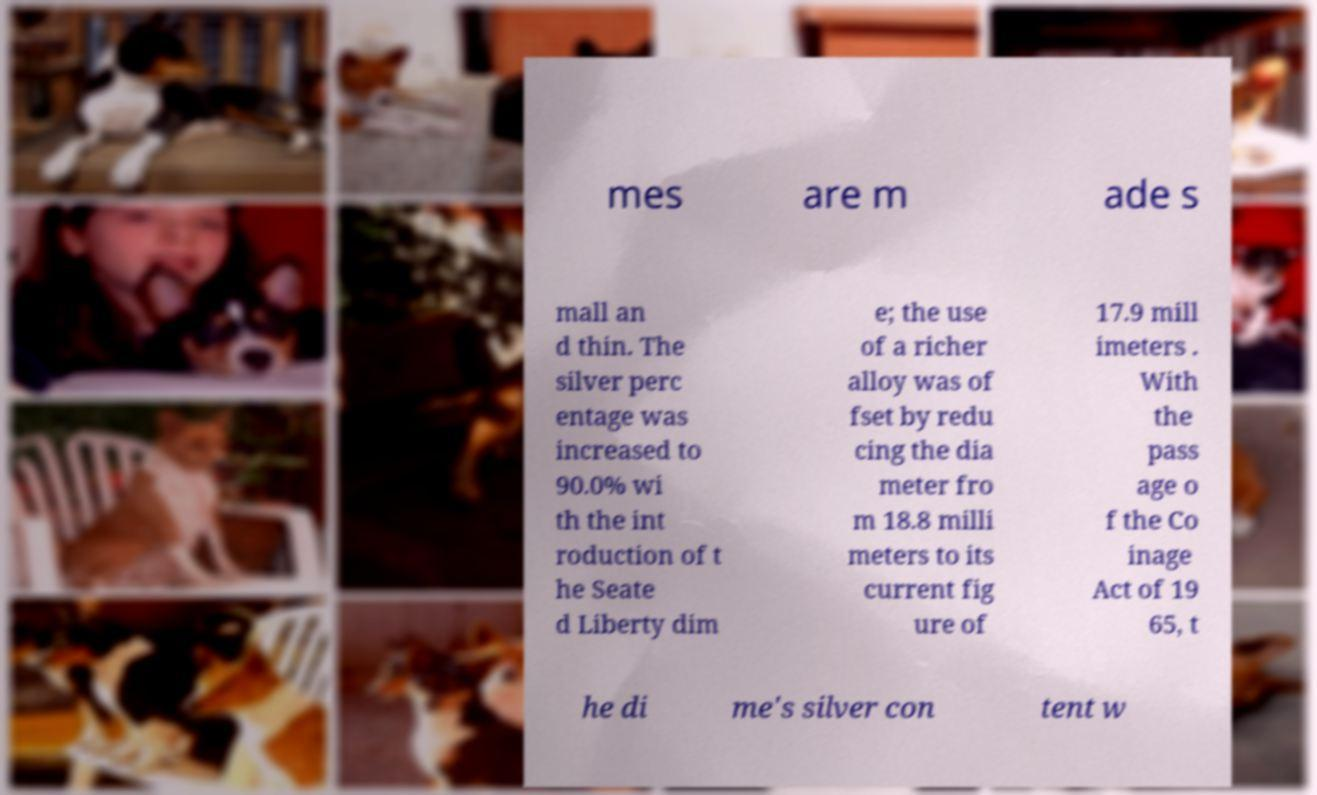I need the written content from this picture converted into text. Can you do that? mes are m ade s mall an d thin. The silver perc entage was increased to 90.0% wi th the int roduction of t he Seate d Liberty dim e; the use of a richer alloy was of fset by redu cing the dia meter fro m 18.8 milli meters to its current fig ure of 17.9 mill imeters . With the pass age o f the Co inage Act of 19 65, t he di me's silver con tent w 